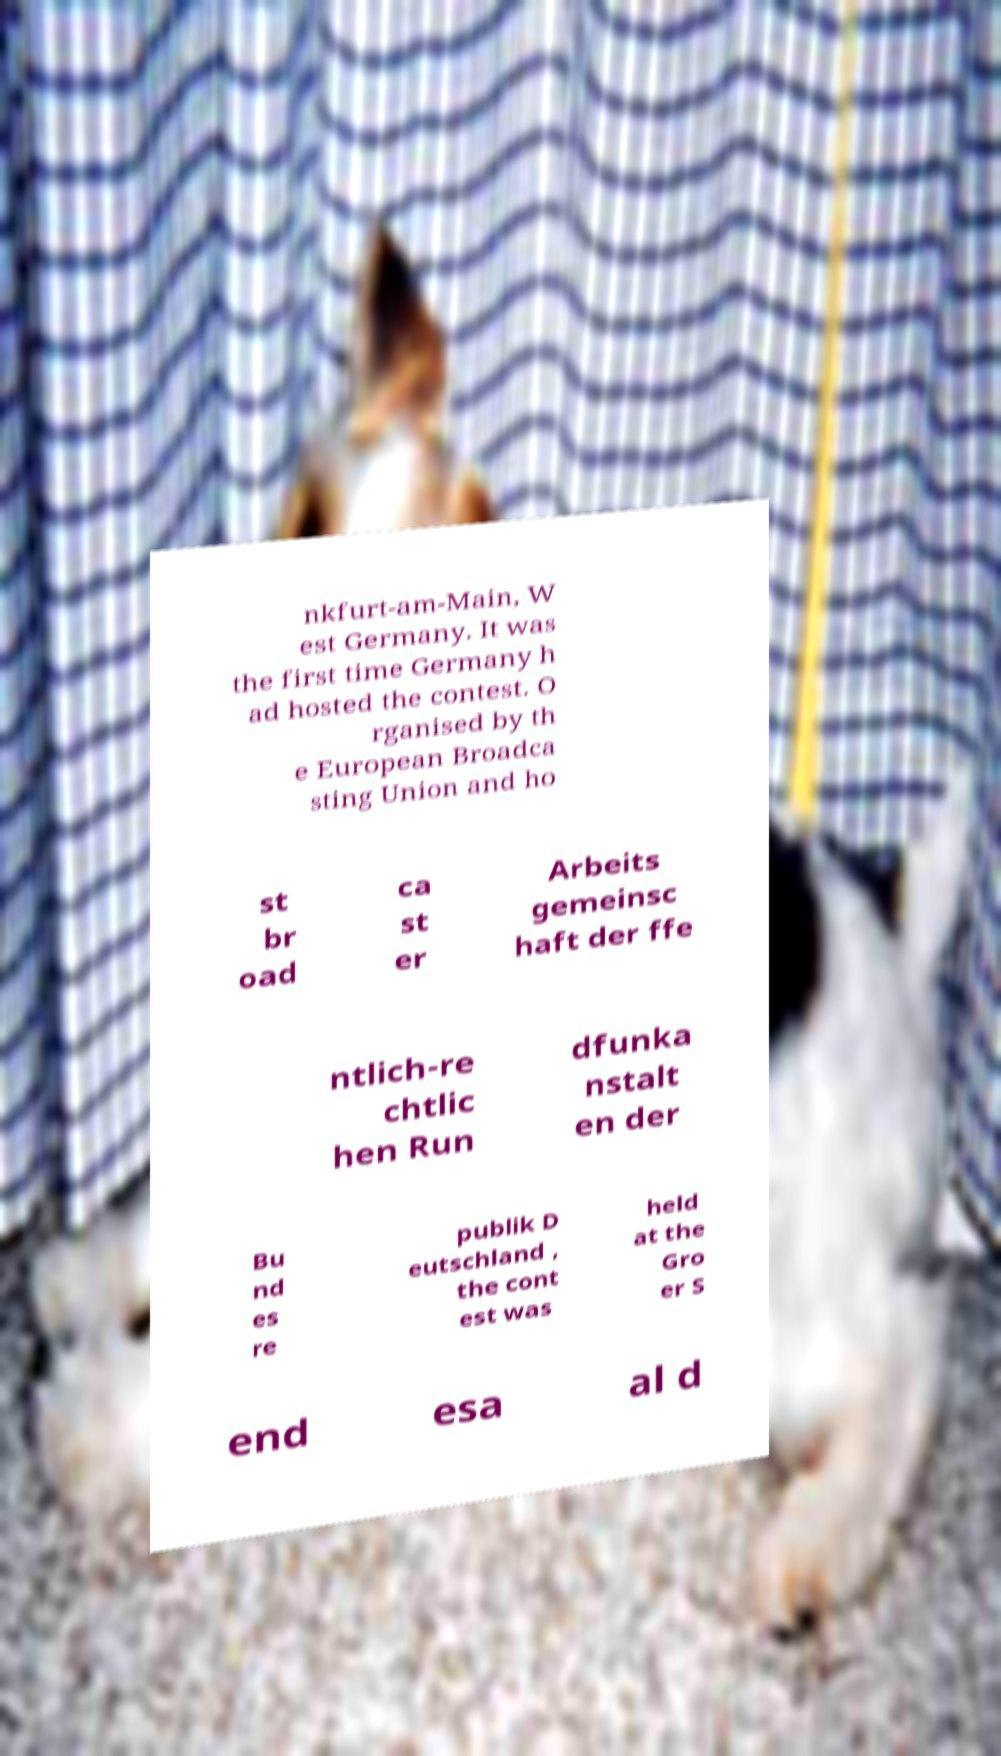What messages or text are displayed in this image? I need them in a readable, typed format. nkfurt-am-Main, W est Germany. It was the first time Germany h ad hosted the contest. O rganised by th e European Broadca sting Union and ho st br oad ca st er Arbeits gemeinsc haft der ffe ntlich-re chtlic hen Run dfunka nstalt en der Bu nd es re publik D eutschland , the cont est was held at the Gro er S end esa al d 